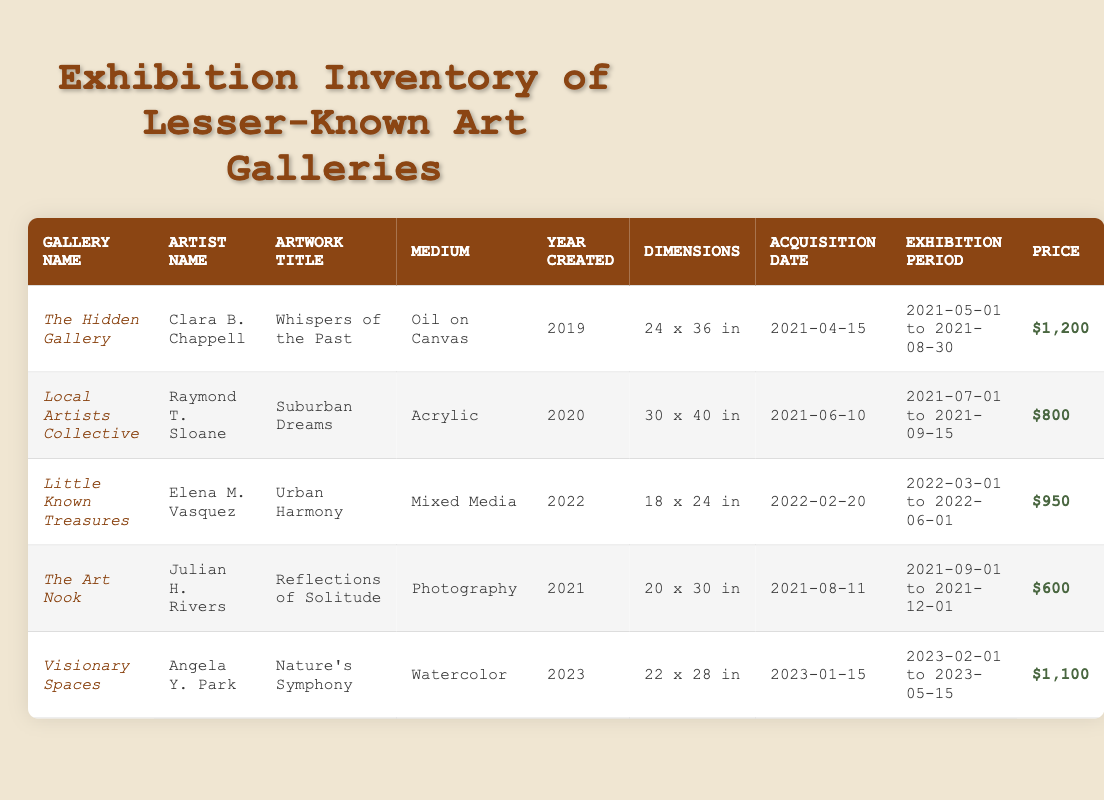What is the title of the artwork by Clara B. Chappell? Referring to the artist Clara B. Chappell in the table, the corresponding artwork title is "Whispers of the Past."
Answer: Whispers of the Past Which artwork has the highest price? By comparing the prices listed in the table, "Whispers of the Past" by Clara B. Chappell is priced at $1200, which is the highest among all the artworks.
Answer: Whispers of the Past Did any artworks exhibit in 2021? Checking the exhibition period column, multiple artworks such as "Whispers of the Past" and "Suburban Dreams" exhibit in 2021, confirming that there are artworks that exhibit that year.
Answer: Yes What is the average price of artworks created in 2022? The artworks created in 2022 are "Urban Harmony" priced at $950. The average price is simply $950 since there is only one artwork from that year.
Answer: 950 Which medium is used by the artist Angela Y. Park? Looking at the entry for Angela Y. Park, we see that her artwork "Nature's Symphony" is created using watercolor.
Answer: Watercolor Is there an artwork created in 2023? The entry for the artwork "Nature's Symphony" shows it was created in the year 2023, confirming that there is an artwork from that year in the table.
Answer: Yes Which gallery exhibits the artwork "Urban Harmony"? In the table, "Urban Harmony," created by Elena M. Vasquez, is listed under the gallery "Little Known Treasures."
Answer: Little Known Treasures How many artworks are exhibited in total? Counting all the rows in the table, there are five artworks listed, indicating a total of five exhibitions in this dataset.
Answer: 5 What is the dimension of the artwork "Reflections of Solitude"? Looking at the entry for "Reflections of Solitude," its dimensions are specified as "20 x 30 in."
Answer: 20 x 30 in What is the difference in price between "Nature's Symphony" and "Suburban Dreams"? The price of "Nature's Symphony" is $1100 and "Suburban Dreams" is $800. The difference is calculated as $1100 - $800 = $300.
Answer: 300 